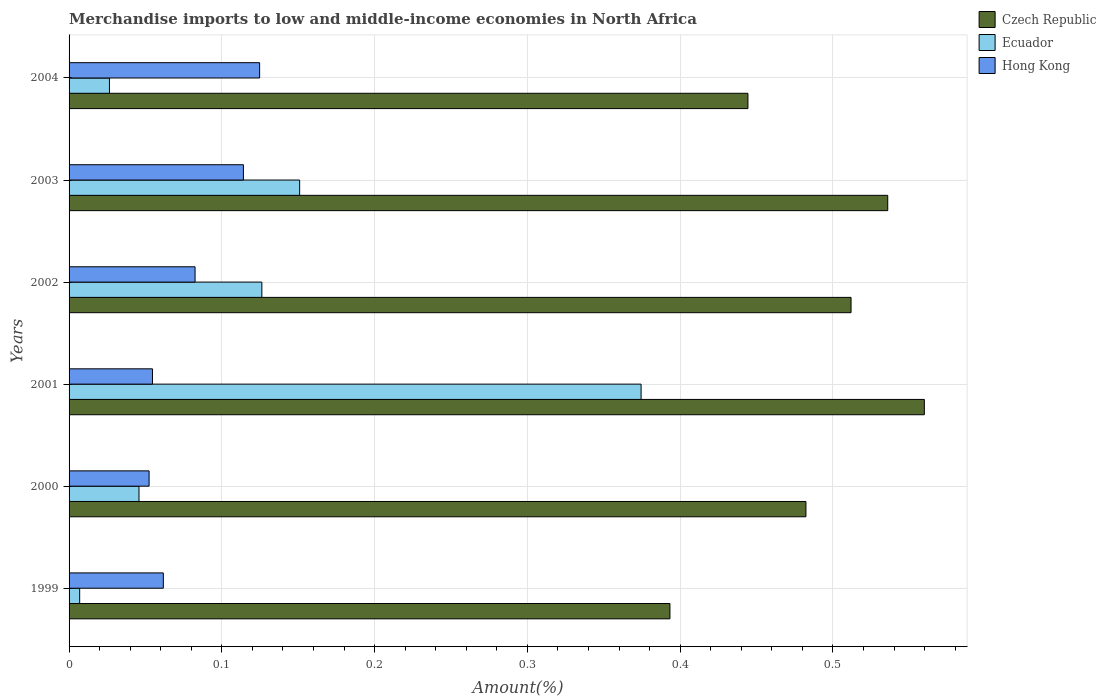How many groups of bars are there?
Your answer should be compact. 6. How many bars are there on the 2nd tick from the bottom?
Give a very brief answer. 3. What is the percentage of amount earned from merchandise imports in Hong Kong in 2000?
Provide a succinct answer. 0.05. Across all years, what is the maximum percentage of amount earned from merchandise imports in Czech Republic?
Provide a succinct answer. 0.56. Across all years, what is the minimum percentage of amount earned from merchandise imports in Czech Republic?
Keep it short and to the point. 0.39. In which year was the percentage of amount earned from merchandise imports in Hong Kong minimum?
Ensure brevity in your answer.  2000. What is the total percentage of amount earned from merchandise imports in Ecuador in the graph?
Your response must be concise. 0.73. What is the difference between the percentage of amount earned from merchandise imports in Hong Kong in 1999 and that in 2001?
Offer a terse response. 0.01. What is the difference between the percentage of amount earned from merchandise imports in Czech Republic in 2003 and the percentage of amount earned from merchandise imports in Hong Kong in 2002?
Offer a terse response. 0.45. What is the average percentage of amount earned from merchandise imports in Hong Kong per year?
Make the answer very short. 0.08. In the year 1999, what is the difference between the percentage of amount earned from merchandise imports in Czech Republic and percentage of amount earned from merchandise imports in Hong Kong?
Your answer should be very brief. 0.33. What is the ratio of the percentage of amount earned from merchandise imports in Czech Republic in 2003 to that in 2004?
Your answer should be very brief. 1.21. Is the percentage of amount earned from merchandise imports in Czech Republic in 1999 less than that in 2002?
Your answer should be compact. Yes. What is the difference between the highest and the second highest percentage of amount earned from merchandise imports in Hong Kong?
Make the answer very short. 0.01. What is the difference between the highest and the lowest percentage of amount earned from merchandise imports in Hong Kong?
Provide a short and direct response. 0.07. In how many years, is the percentage of amount earned from merchandise imports in Ecuador greater than the average percentage of amount earned from merchandise imports in Ecuador taken over all years?
Keep it short and to the point. 3. What does the 3rd bar from the top in 2003 represents?
Give a very brief answer. Czech Republic. What does the 3rd bar from the bottom in 1999 represents?
Your answer should be very brief. Hong Kong. Is it the case that in every year, the sum of the percentage of amount earned from merchandise imports in Hong Kong and percentage of amount earned from merchandise imports in Czech Republic is greater than the percentage of amount earned from merchandise imports in Ecuador?
Make the answer very short. Yes. How many years are there in the graph?
Your answer should be very brief. 6. Are the values on the major ticks of X-axis written in scientific E-notation?
Offer a very short reply. No. Does the graph contain any zero values?
Provide a succinct answer. No. How many legend labels are there?
Keep it short and to the point. 3. How are the legend labels stacked?
Make the answer very short. Vertical. What is the title of the graph?
Provide a succinct answer. Merchandise imports to low and middle-income economies in North Africa. What is the label or title of the X-axis?
Your answer should be very brief. Amount(%). What is the label or title of the Y-axis?
Give a very brief answer. Years. What is the Amount(%) of Czech Republic in 1999?
Offer a terse response. 0.39. What is the Amount(%) of Ecuador in 1999?
Offer a very short reply. 0.01. What is the Amount(%) in Hong Kong in 1999?
Provide a succinct answer. 0.06. What is the Amount(%) in Czech Republic in 2000?
Ensure brevity in your answer.  0.48. What is the Amount(%) of Ecuador in 2000?
Provide a short and direct response. 0.05. What is the Amount(%) in Hong Kong in 2000?
Your response must be concise. 0.05. What is the Amount(%) in Czech Republic in 2001?
Provide a short and direct response. 0.56. What is the Amount(%) of Ecuador in 2001?
Offer a very short reply. 0.37. What is the Amount(%) of Hong Kong in 2001?
Give a very brief answer. 0.05. What is the Amount(%) of Czech Republic in 2002?
Provide a short and direct response. 0.51. What is the Amount(%) of Ecuador in 2002?
Provide a succinct answer. 0.13. What is the Amount(%) in Hong Kong in 2002?
Offer a very short reply. 0.08. What is the Amount(%) of Czech Republic in 2003?
Make the answer very short. 0.54. What is the Amount(%) in Ecuador in 2003?
Offer a terse response. 0.15. What is the Amount(%) of Hong Kong in 2003?
Provide a short and direct response. 0.11. What is the Amount(%) in Czech Republic in 2004?
Give a very brief answer. 0.44. What is the Amount(%) of Ecuador in 2004?
Offer a very short reply. 0.03. What is the Amount(%) of Hong Kong in 2004?
Offer a very short reply. 0.12. Across all years, what is the maximum Amount(%) in Czech Republic?
Give a very brief answer. 0.56. Across all years, what is the maximum Amount(%) in Ecuador?
Give a very brief answer. 0.37. Across all years, what is the maximum Amount(%) of Hong Kong?
Keep it short and to the point. 0.12. Across all years, what is the minimum Amount(%) in Czech Republic?
Make the answer very short. 0.39. Across all years, what is the minimum Amount(%) in Ecuador?
Offer a terse response. 0.01. Across all years, what is the minimum Amount(%) in Hong Kong?
Provide a short and direct response. 0.05. What is the total Amount(%) of Czech Republic in the graph?
Provide a short and direct response. 2.93. What is the total Amount(%) of Ecuador in the graph?
Keep it short and to the point. 0.73. What is the total Amount(%) of Hong Kong in the graph?
Keep it short and to the point. 0.49. What is the difference between the Amount(%) in Czech Republic in 1999 and that in 2000?
Provide a short and direct response. -0.09. What is the difference between the Amount(%) of Ecuador in 1999 and that in 2000?
Offer a terse response. -0.04. What is the difference between the Amount(%) in Hong Kong in 1999 and that in 2000?
Keep it short and to the point. 0.01. What is the difference between the Amount(%) in Czech Republic in 1999 and that in 2001?
Your answer should be compact. -0.17. What is the difference between the Amount(%) of Ecuador in 1999 and that in 2001?
Give a very brief answer. -0.37. What is the difference between the Amount(%) in Hong Kong in 1999 and that in 2001?
Your answer should be compact. 0.01. What is the difference between the Amount(%) of Czech Republic in 1999 and that in 2002?
Provide a succinct answer. -0.12. What is the difference between the Amount(%) in Ecuador in 1999 and that in 2002?
Give a very brief answer. -0.12. What is the difference between the Amount(%) of Hong Kong in 1999 and that in 2002?
Provide a succinct answer. -0.02. What is the difference between the Amount(%) in Czech Republic in 1999 and that in 2003?
Make the answer very short. -0.14. What is the difference between the Amount(%) of Ecuador in 1999 and that in 2003?
Your response must be concise. -0.14. What is the difference between the Amount(%) of Hong Kong in 1999 and that in 2003?
Keep it short and to the point. -0.05. What is the difference between the Amount(%) of Czech Republic in 1999 and that in 2004?
Make the answer very short. -0.05. What is the difference between the Amount(%) of Ecuador in 1999 and that in 2004?
Your answer should be compact. -0.02. What is the difference between the Amount(%) of Hong Kong in 1999 and that in 2004?
Your answer should be very brief. -0.06. What is the difference between the Amount(%) of Czech Republic in 2000 and that in 2001?
Offer a terse response. -0.08. What is the difference between the Amount(%) of Ecuador in 2000 and that in 2001?
Provide a short and direct response. -0.33. What is the difference between the Amount(%) of Hong Kong in 2000 and that in 2001?
Your answer should be very brief. -0. What is the difference between the Amount(%) of Czech Republic in 2000 and that in 2002?
Offer a very short reply. -0.03. What is the difference between the Amount(%) of Ecuador in 2000 and that in 2002?
Your answer should be compact. -0.08. What is the difference between the Amount(%) in Hong Kong in 2000 and that in 2002?
Make the answer very short. -0.03. What is the difference between the Amount(%) in Czech Republic in 2000 and that in 2003?
Give a very brief answer. -0.05. What is the difference between the Amount(%) in Ecuador in 2000 and that in 2003?
Offer a very short reply. -0.11. What is the difference between the Amount(%) of Hong Kong in 2000 and that in 2003?
Make the answer very short. -0.06. What is the difference between the Amount(%) of Czech Republic in 2000 and that in 2004?
Ensure brevity in your answer.  0.04. What is the difference between the Amount(%) in Ecuador in 2000 and that in 2004?
Offer a very short reply. 0.02. What is the difference between the Amount(%) of Hong Kong in 2000 and that in 2004?
Give a very brief answer. -0.07. What is the difference between the Amount(%) of Czech Republic in 2001 and that in 2002?
Ensure brevity in your answer.  0.05. What is the difference between the Amount(%) in Ecuador in 2001 and that in 2002?
Your answer should be compact. 0.25. What is the difference between the Amount(%) of Hong Kong in 2001 and that in 2002?
Your response must be concise. -0.03. What is the difference between the Amount(%) of Czech Republic in 2001 and that in 2003?
Your response must be concise. 0.02. What is the difference between the Amount(%) in Ecuador in 2001 and that in 2003?
Your response must be concise. 0.22. What is the difference between the Amount(%) of Hong Kong in 2001 and that in 2003?
Provide a short and direct response. -0.06. What is the difference between the Amount(%) of Czech Republic in 2001 and that in 2004?
Ensure brevity in your answer.  0.12. What is the difference between the Amount(%) in Ecuador in 2001 and that in 2004?
Your answer should be compact. 0.35. What is the difference between the Amount(%) of Hong Kong in 2001 and that in 2004?
Keep it short and to the point. -0.07. What is the difference between the Amount(%) in Czech Republic in 2002 and that in 2003?
Ensure brevity in your answer.  -0.02. What is the difference between the Amount(%) of Ecuador in 2002 and that in 2003?
Keep it short and to the point. -0.02. What is the difference between the Amount(%) of Hong Kong in 2002 and that in 2003?
Your response must be concise. -0.03. What is the difference between the Amount(%) in Czech Republic in 2002 and that in 2004?
Provide a short and direct response. 0.07. What is the difference between the Amount(%) of Ecuador in 2002 and that in 2004?
Your answer should be very brief. 0.1. What is the difference between the Amount(%) of Hong Kong in 2002 and that in 2004?
Provide a short and direct response. -0.04. What is the difference between the Amount(%) in Czech Republic in 2003 and that in 2004?
Provide a short and direct response. 0.09. What is the difference between the Amount(%) in Ecuador in 2003 and that in 2004?
Your answer should be very brief. 0.12. What is the difference between the Amount(%) in Hong Kong in 2003 and that in 2004?
Keep it short and to the point. -0.01. What is the difference between the Amount(%) of Czech Republic in 1999 and the Amount(%) of Ecuador in 2000?
Give a very brief answer. 0.35. What is the difference between the Amount(%) in Czech Republic in 1999 and the Amount(%) in Hong Kong in 2000?
Keep it short and to the point. 0.34. What is the difference between the Amount(%) of Ecuador in 1999 and the Amount(%) of Hong Kong in 2000?
Provide a succinct answer. -0.05. What is the difference between the Amount(%) of Czech Republic in 1999 and the Amount(%) of Ecuador in 2001?
Offer a terse response. 0.02. What is the difference between the Amount(%) of Czech Republic in 1999 and the Amount(%) of Hong Kong in 2001?
Your answer should be very brief. 0.34. What is the difference between the Amount(%) in Ecuador in 1999 and the Amount(%) in Hong Kong in 2001?
Give a very brief answer. -0.05. What is the difference between the Amount(%) in Czech Republic in 1999 and the Amount(%) in Ecuador in 2002?
Offer a terse response. 0.27. What is the difference between the Amount(%) of Czech Republic in 1999 and the Amount(%) of Hong Kong in 2002?
Provide a succinct answer. 0.31. What is the difference between the Amount(%) in Ecuador in 1999 and the Amount(%) in Hong Kong in 2002?
Your answer should be very brief. -0.08. What is the difference between the Amount(%) of Czech Republic in 1999 and the Amount(%) of Ecuador in 2003?
Give a very brief answer. 0.24. What is the difference between the Amount(%) in Czech Republic in 1999 and the Amount(%) in Hong Kong in 2003?
Provide a short and direct response. 0.28. What is the difference between the Amount(%) of Ecuador in 1999 and the Amount(%) of Hong Kong in 2003?
Your answer should be very brief. -0.11. What is the difference between the Amount(%) in Czech Republic in 1999 and the Amount(%) in Ecuador in 2004?
Provide a succinct answer. 0.37. What is the difference between the Amount(%) of Czech Republic in 1999 and the Amount(%) of Hong Kong in 2004?
Offer a terse response. 0.27. What is the difference between the Amount(%) of Ecuador in 1999 and the Amount(%) of Hong Kong in 2004?
Offer a very short reply. -0.12. What is the difference between the Amount(%) of Czech Republic in 2000 and the Amount(%) of Ecuador in 2001?
Keep it short and to the point. 0.11. What is the difference between the Amount(%) in Czech Republic in 2000 and the Amount(%) in Hong Kong in 2001?
Your answer should be compact. 0.43. What is the difference between the Amount(%) in Ecuador in 2000 and the Amount(%) in Hong Kong in 2001?
Provide a succinct answer. -0.01. What is the difference between the Amount(%) of Czech Republic in 2000 and the Amount(%) of Ecuador in 2002?
Make the answer very short. 0.36. What is the difference between the Amount(%) in Czech Republic in 2000 and the Amount(%) in Hong Kong in 2002?
Provide a succinct answer. 0.4. What is the difference between the Amount(%) of Ecuador in 2000 and the Amount(%) of Hong Kong in 2002?
Provide a short and direct response. -0.04. What is the difference between the Amount(%) in Czech Republic in 2000 and the Amount(%) in Ecuador in 2003?
Keep it short and to the point. 0.33. What is the difference between the Amount(%) in Czech Republic in 2000 and the Amount(%) in Hong Kong in 2003?
Your answer should be compact. 0.37. What is the difference between the Amount(%) of Ecuador in 2000 and the Amount(%) of Hong Kong in 2003?
Your answer should be compact. -0.07. What is the difference between the Amount(%) in Czech Republic in 2000 and the Amount(%) in Ecuador in 2004?
Provide a succinct answer. 0.46. What is the difference between the Amount(%) in Czech Republic in 2000 and the Amount(%) in Hong Kong in 2004?
Your answer should be very brief. 0.36. What is the difference between the Amount(%) in Ecuador in 2000 and the Amount(%) in Hong Kong in 2004?
Ensure brevity in your answer.  -0.08. What is the difference between the Amount(%) in Czech Republic in 2001 and the Amount(%) in Ecuador in 2002?
Your response must be concise. 0.43. What is the difference between the Amount(%) of Czech Republic in 2001 and the Amount(%) of Hong Kong in 2002?
Provide a short and direct response. 0.48. What is the difference between the Amount(%) in Ecuador in 2001 and the Amount(%) in Hong Kong in 2002?
Ensure brevity in your answer.  0.29. What is the difference between the Amount(%) in Czech Republic in 2001 and the Amount(%) in Ecuador in 2003?
Your response must be concise. 0.41. What is the difference between the Amount(%) of Czech Republic in 2001 and the Amount(%) of Hong Kong in 2003?
Provide a succinct answer. 0.45. What is the difference between the Amount(%) in Ecuador in 2001 and the Amount(%) in Hong Kong in 2003?
Make the answer very short. 0.26. What is the difference between the Amount(%) in Czech Republic in 2001 and the Amount(%) in Ecuador in 2004?
Your response must be concise. 0.53. What is the difference between the Amount(%) in Czech Republic in 2001 and the Amount(%) in Hong Kong in 2004?
Your response must be concise. 0.44. What is the difference between the Amount(%) in Ecuador in 2001 and the Amount(%) in Hong Kong in 2004?
Offer a very short reply. 0.25. What is the difference between the Amount(%) in Czech Republic in 2002 and the Amount(%) in Ecuador in 2003?
Give a very brief answer. 0.36. What is the difference between the Amount(%) in Czech Republic in 2002 and the Amount(%) in Hong Kong in 2003?
Offer a terse response. 0.4. What is the difference between the Amount(%) in Ecuador in 2002 and the Amount(%) in Hong Kong in 2003?
Provide a short and direct response. 0.01. What is the difference between the Amount(%) of Czech Republic in 2002 and the Amount(%) of Ecuador in 2004?
Ensure brevity in your answer.  0.49. What is the difference between the Amount(%) in Czech Republic in 2002 and the Amount(%) in Hong Kong in 2004?
Give a very brief answer. 0.39. What is the difference between the Amount(%) of Ecuador in 2002 and the Amount(%) of Hong Kong in 2004?
Make the answer very short. 0. What is the difference between the Amount(%) of Czech Republic in 2003 and the Amount(%) of Ecuador in 2004?
Give a very brief answer. 0.51. What is the difference between the Amount(%) in Czech Republic in 2003 and the Amount(%) in Hong Kong in 2004?
Provide a succinct answer. 0.41. What is the difference between the Amount(%) of Ecuador in 2003 and the Amount(%) of Hong Kong in 2004?
Your response must be concise. 0.03. What is the average Amount(%) in Czech Republic per year?
Provide a short and direct response. 0.49. What is the average Amount(%) of Ecuador per year?
Offer a terse response. 0.12. What is the average Amount(%) of Hong Kong per year?
Ensure brevity in your answer.  0.08. In the year 1999, what is the difference between the Amount(%) of Czech Republic and Amount(%) of Ecuador?
Your response must be concise. 0.39. In the year 1999, what is the difference between the Amount(%) of Czech Republic and Amount(%) of Hong Kong?
Offer a terse response. 0.33. In the year 1999, what is the difference between the Amount(%) in Ecuador and Amount(%) in Hong Kong?
Offer a terse response. -0.05. In the year 2000, what is the difference between the Amount(%) of Czech Republic and Amount(%) of Ecuador?
Ensure brevity in your answer.  0.44. In the year 2000, what is the difference between the Amount(%) of Czech Republic and Amount(%) of Hong Kong?
Provide a succinct answer. 0.43. In the year 2000, what is the difference between the Amount(%) in Ecuador and Amount(%) in Hong Kong?
Provide a short and direct response. -0.01. In the year 2001, what is the difference between the Amount(%) in Czech Republic and Amount(%) in Ecuador?
Provide a short and direct response. 0.19. In the year 2001, what is the difference between the Amount(%) in Czech Republic and Amount(%) in Hong Kong?
Keep it short and to the point. 0.51. In the year 2001, what is the difference between the Amount(%) of Ecuador and Amount(%) of Hong Kong?
Your answer should be very brief. 0.32. In the year 2002, what is the difference between the Amount(%) in Czech Republic and Amount(%) in Ecuador?
Offer a terse response. 0.39. In the year 2002, what is the difference between the Amount(%) in Czech Republic and Amount(%) in Hong Kong?
Provide a short and direct response. 0.43. In the year 2002, what is the difference between the Amount(%) of Ecuador and Amount(%) of Hong Kong?
Your answer should be compact. 0.04. In the year 2003, what is the difference between the Amount(%) in Czech Republic and Amount(%) in Ecuador?
Your answer should be very brief. 0.38. In the year 2003, what is the difference between the Amount(%) of Czech Republic and Amount(%) of Hong Kong?
Keep it short and to the point. 0.42. In the year 2003, what is the difference between the Amount(%) in Ecuador and Amount(%) in Hong Kong?
Your response must be concise. 0.04. In the year 2004, what is the difference between the Amount(%) of Czech Republic and Amount(%) of Ecuador?
Your answer should be very brief. 0.42. In the year 2004, what is the difference between the Amount(%) in Czech Republic and Amount(%) in Hong Kong?
Your answer should be compact. 0.32. In the year 2004, what is the difference between the Amount(%) of Ecuador and Amount(%) of Hong Kong?
Keep it short and to the point. -0.1. What is the ratio of the Amount(%) of Czech Republic in 1999 to that in 2000?
Your answer should be very brief. 0.82. What is the ratio of the Amount(%) of Ecuador in 1999 to that in 2000?
Keep it short and to the point. 0.15. What is the ratio of the Amount(%) of Hong Kong in 1999 to that in 2000?
Offer a terse response. 1.18. What is the ratio of the Amount(%) in Czech Republic in 1999 to that in 2001?
Make the answer very short. 0.7. What is the ratio of the Amount(%) of Ecuador in 1999 to that in 2001?
Your answer should be very brief. 0.02. What is the ratio of the Amount(%) in Hong Kong in 1999 to that in 2001?
Your answer should be very brief. 1.13. What is the ratio of the Amount(%) of Czech Republic in 1999 to that in 2002?
Ensure brevity in your answer.  0.77. What is the ratio of the Amount(%) of Ecuador in 1999 to that in 2002?
Your response must be concise. 0.06. What is the ratio of the Amount(%) of Hong Kong in 1999 to that in 2002?
Make the answer very short. 0.75. What is the ratio of the Amount(%) of Czech Republic in 1999 to that in 2003?
Your response must be concise. 0.73. What is the ratio of the Amount(%) in Ecuador in 1999 to that in 2003?
Offer a terse response. 0.05. What is the ratio of the Amount(%) in Hong Kong in 1999 to that in 2003?
Offer a very short reply. 0.54. What is the ratio of the Amount(%) of Czech Republic in 1999 to that in 2004?
Give a very brief answer. 0.89. What is the ratio of the Amount(%) in Ecuador in 1999 to that in 2004?
Your answer should be very brief. 0.26. What is the ratio of the Amount(%) of Hong Kong in 1999 to that in 2004?
Make the answer very short. 0.49. What is the ratio of the Amount(%) in Czech Republic in 2000 to that in 2001?
Provide a short and direct response. 0.86. What is the ratio of the Amount(%) of Ecuador in 2000 to that in 2001?
Give a very brief answer. 0.12. What is the ratio of the Amount(%) in Hong Kong in 2000 to that in 2001?
Give a very brief answer. 0.96. What is the ratio of the Amount(%) in Czech Republic in 2000 to that in 2002?
Make the answer very short. 0.94. What is the ratio of the Amount(%) in Ecuador in 2000 to that in 2002?
Your response must be concise. 0.36. What is the ratio of the Amount(%) in Hong Kong in 2000 to that in 2002?
Keep it short and to the point. 0.64. What is the ratio of the Amount(%) in Czech Republic in 2000 to that in 2003?
Offer a terse response. 0.9. What is the ratio of the Amount(%) of Ecuador in 2000 to that in 2003?
Provide a succinct answer. 0.3. What is the ratio of the Amount(%) in Hong Kong in 2000 to that in 2003?
Your answer should be very brief. 0.46. What is the ratio of the Amount(%) in Czech Republic in 2000 to that in 2004?
Ensure brevity in your answer.  1.09. What is the ratio of the Amount(%) of Ecuador in 2000 to that in 2004?
Ensure brevity in your answer.  1.73. What is the ratio of the Amount(%) of Hong Kong in 2000 to that in 2004?
Keep it short and to the point. 0.42. What is the ratio of the Amount(%) of Czech Republic in 2001 to that in 2002?
Offer a very short reply. 1.09. What is the ratio of the Amount(%) of Ecuador in 2001 to that in 2002?
Offer a terse response. 2.97. What is the ratio of the Amount(%) of Hong Kong in 2001 to that in 2002?
Provide a succinct answer. 0.66. What is the ratio of the Amount(%) of Czech Republic in 2001 to that in 2003?
Your response must be concise. 1.04. What is the ratio of the Amount(%) of Ecuador in 2001 to that in 2003?
Offer a very short reply. 2.48. What is the ratio of the Amount(%) in Hong Kong in 2001 to that in 2003?
Keep it short and to the point. 0.48. What is the ratio of the Amount(%) in Czech Republic in 2001 to that in 2004?
Make the answer very short. 1.26. What is the ratio of the Amount(%) of Ecuador in 2001 to that in 2004?
Keep it short and to the point. 14.16. What is the ratio of the Amount(%) in Hong Kong in 2001 to that in 2004?
Give a very brief answer. 0.44. What is the ratio of the Amount(%) in Czech Republic in 2002 to that in 2003?
Your response must be concise. 0.96. What is the ratio of the Amount(%) of Ecuador in 2002 to that in 2003?
Provide a succinct answer. 0.84. What is the ratio of the Amount(%) in Hong Kong in 2002 to that in 2003?
Your response must be concise. 0.72. What is the ratio of the Amount(%) of Czech Republic in 2002 to that in 2004?
Your response must be concise. 1.15. What is the ratio of the Amount(%) of Ecuador in 2002 to that in 2004?
Provide a succinct answer. 4.77. What is the ratio of the Amount(%) of Hong Kong in 2002 to that in 2004?
Provide a short and direct response. 0.66. What is the ratio of the Amount(%) of Czech Republic in 2003 to that in 2004?
Offer a terse response. 1.21. What is the ratio of the Amount(%) in Ecuador in 2003 to that in 2004?
Your answer should be very brief. 5.71. What is the ratio of the Amount(%) of Hong Kong in 2003 to that in 2004?
Your response must be concise. 0.91. What is the difference between the highest and the second highest Amount(%) of Czech Republic?
Offer a terse response. 0.02. What is the difference between the highest and the second highest Amount(%) in Ecuador?
Your answer should be very brief. 0.22. What is the difference between the highest and the second highest Amount(%) in Hong Kong?
Provide a short and direct response. 0.01. What is the difference between the highest and the lowest Amount(%) in Czech Republic?
Ensure brevity in your answer.  0.17. What is the difference between the highest and the lowest Amount(%) of Ecuador?
Your response must be concise. 0.37. What is the difference between the highest and the lowest Amount(%) in Hong Kong?
Offer a terse response. 0.07. 